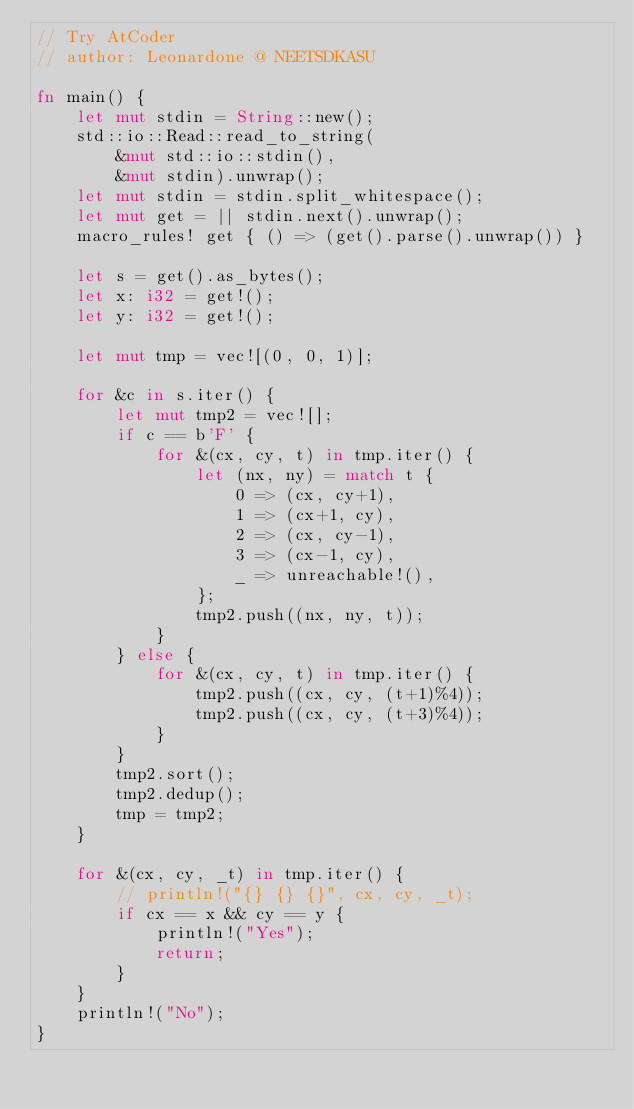Convert code to text. <code><loc_0><loc_0><loc_500><loc_500><_Rust_>// Try AtCoder
// author: Leonardone @ NEETSDKASU

fn main() {
    let mut stdin = String::new();
    std::io::Read::read_to_string(
    	&mut std::io::stdin(),
        &mut stdin).unwrap();
    let mut stdin = stdin.split_whitespace();
    let mut get = || stdin.next().unwrap();
    macro_rules! get { () => (get().parse().unwrap()) }
    
    let s = get().as_bytes();
    let x: i32 = get!();
    let y: i32 = get!();
    
    let mut tmp = vec![(0, 0, 1)];
    
    for &c in s.iter() {
    	let mut tmp2 = vec![];
    	if c == b'F' {
    		for &(cx, cy, t) in tmp.iter() {
        		let (nx, ny) = match t {
                	0 => (cx, cy+1),
                	1 => (cx+1, cy),
                	2 => (cx, cy-1),
                    3 => (cx-1, cy),
                    _ => unreachable!(),
                };
                tmp2.push((nx, ny, t));
        	}
        } else {
    		for &(cx, cy, t) in tmp.iter() {
            	tmp2.push((cx, cy, (t+1)%4));
                tmp2.push((cx, cy, (t+3)%4));
            }
        }
        tmp2.sort();
        tmp2.dedup();
        tmp = tmp2;
    }
    
    for &(cx, cy, _t) in tmp.iter() {
    	// println!("{} {} {}", cx, cy, _t);
    	if cx == x && cy == y {
        	println!("Yes");
            return;
        }
    }
    println!("No");
}</code> 